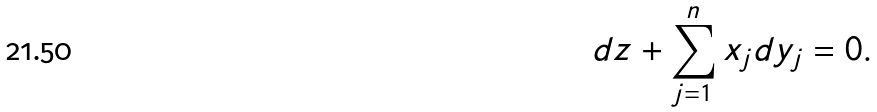<formula> <loc_0><loc_0><loc_500><loc_500>d z + \sum _ { j = 1 } ^ { n } x _ { j } d y _ { j } = 0 .</formula> 